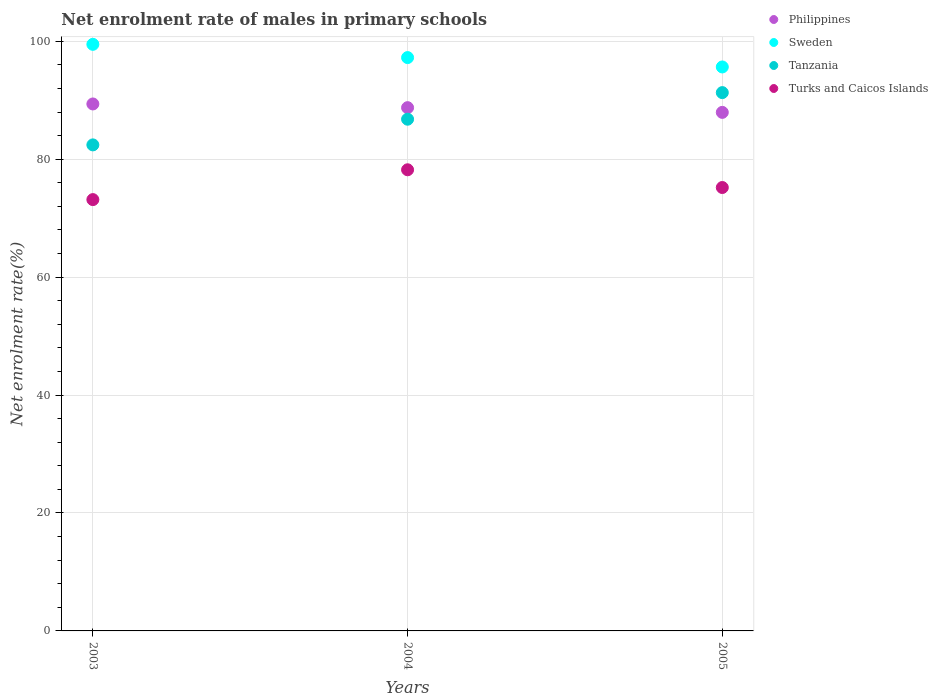What is the net enrolment rate of males in primary schools in Philippines in 2004?
Keep it short and to the point. 88.75. Across all years, what is the maximum net enrolment rate of males in primary schools in Philippines?
Provide a succinct answer. 89.37. Across all years, what is the minimum net enrolment rate of males in primary schools in Turks and Caicos Islands?
Your answer should be compact. 73.15. What is the total net enrolment rate of males in primary schools in Sweden in the graph?
Your answer should be very brief. 292.38. What is the difference between the net enrolment rate of males in primary schools in Philippines in 2003 and that in 2005?
Your answer should be compact. 1.43. What is the difference between the net enrolment rate of males in primary schools in Turks and Caicos Islands in 2003 and the net enrolment rate of males in primary schools in Philippines in 2005?
Make the answer very short. -14.79. What is the average net enrolment rate of males in primary schools in Philippines per year?
Give a very brief answer. 88.69. In the year 2005, what is the difference between the net enrolment rate of males in primary schools in Tanzania and net enrolment rate of males in primary schools in Sweden?
Offer a very short reply. -4.35. What is the ratio of the net enrolment rate of males in primary schools in Sweden in 2004 to that in 2005?
Provide a succinct answer. 1.02. Is the difference between the net enrolment rate of males in primary schools in Tanzania in 2003 and 2005 greater than the difference between the net enrolment rate of males in primary schools in Sweden in 2003 and 2005?
Offer a terse response. No. What is the difference between the highest and the second highest net enrolment rate of males in primary schools in Tanzania?
Make the answer very short. 4.51. What is the difference between the highest and the lowest net enrolment rate of males in primary schools in Philippines?
Ensure brevity in your answer.  1.43. In how many years, is the net enrolment rate of males in primary schools in Sweden greater than the average net enrolment rate of males in primary schools in Sweden taken over all years?
Keep it short and to the point. 1. Is the sum of the net enrolment rate of males in primary schools in Tanzania in 2003 and 2004 greater than the maximum net enrolment rate of males in primary schools in Sweden across all years?
Give a very brief answer. Yes. Is it the case that in every year, the sum of the net enrolment rate of males in primary schools in Tanzania and net enrolment rate of males in primary schools in Philippines  is greater than the sum of net enrolment rate of males in primary schools in Sweden and net enrolment rate of males in primary schools in Turks and Caicos Islands?
Ensure brevity in your answer.  No. Is it the case that in every year, the sum of the net enrolment rate of males in primary schools in Sweden and net enrolment rate of males in primary schools in Turks and Caicos Islands  is greater than the net enrolment rate of males in primary schools in Philippines?
Make the answer very short. Yes. How many dotlines are there?
Your response must be concise. 4. What is the difference between two consecutive major ticks on the Y-axis?
Offer a very short reply. 20. Are the values on the major ticks of Y-axis written in scientific E-notation?
Offer a terse response. No. Does the graph contain any zero values?
Offer a very short reply. No. Does the graph contain grids?
Give a very brief answer. Yes. Where does the legend appear in the graph?
Provide a short and direct response. Top right. How many legend labels are there?
Your answer should be very brief. 4. How are the legend labels stacked?
Offer a very short reply. Vertical. What is the title of the graph?
Offer a very short reply. Net enrolment rate of males in primary schools. Does "Lithuania" appear as one of the legend labels in the graph?
Offer a terse response. No. What is the label or title of the Y-axis?
Make the answer very short. Net enrolment rate(%). What is the Net enrolment rate(%) in Philippines in 2003?
Your response must be concise. 89.37. What is the Net enrolment rate(%) in Sweden in 2003?
Offer a terse response. 99.49. What is the Net enrolment rate(%) of Tanzania in 2003?
Keep it short and to the point. 82.43. What is the Net enrolment rate(%) of Turks and Caicos Islands in 2003?
Keep it short and to the point. 73.15. What is the Net enrolment rate(%) in Philippines in 2004?
Offer a very short reply. 88.75. What is the Net enrolment rate(%) in Sweden in 2004?
Keep it short and to the point. 97.24. What is the Net enrolment rate(%) in Tanzania in 2004?
Offer a very short reply. 86.79. What is the Net enrolment rate(%) in Turks and Caicos Islands in 2004?
Provide a short and direct response. 78.21. What is the Net enrolment rate(%) in Philippines in 2005?
Offer a very short reply. 87.95. What is the Net enrolment rate(%) of Sweden in 2005?
Offer a terse response. 95.65. What is the Net enrolment rate(%) in Tanzania in 2005?
Your answer should be compact. 91.3. What is the Net enrolment rate(%) of Turks and Caicos Islands in 2005?
Provide a succinct answer. 75.2. Across all years, what is the maximum Net enrolment rate(%) of Philippines?
Ensure brevity in your answer.  89.37. Across all years, what is the maximum Net enrolment rate(%) in Sweden?
Your response must be concise. 99.49. Across all years, what is the maximum Net enrolment rate(%) of Tanzania?
Provide a succinct answer. 91.3. Across all years, what is the maximum Net enrolment rate(%) of Turks and Caicos Islands?
Keep it short and to the point. 78.21. Across all years, what is the minimum Net enrolment rate(%) in Philippines?
Keep it short and to the point. 87.95. Across all years, what is the minimum Net enrolment rate(%) of Sweden?
Give a very brief answer. 95.65. Across all years, what is the minimum Net enrolment rate(%) in Tanzania?
Offer a terse response. 82.43. Across all years, what is the minimum Net enrolment rate(%) of Turks and Caicos Islands?
Provide a short and direct response. 73.15. What is the total Net enrolment rate(%) of Philippines in the graph?
Your answer should be very brief. 266.07. What is the total Net enrolment rate(%) of Sweden in the graph?
Ensure brevity in your answer.  292.38. What is the total Net enrolment rate(%) in Tanzania in the graph?
Offer a very short reply. 260.52. What is the total Net enrolment rate(%) in Turks and Caicos Islands in the graph?
Keep it short and to the point. 226.57. What is the difference between the Net enrolment rate(%) of Philippines in 2003 and that in 2004?
Your response must be concise. 0.63. What is the difference between the Net enrolment rate(%) of Sweden in 2003 and that in 2004?
Provide a short and direct response. 2.25. What is the difference between the Net enrolment rate(%) of Tanzania in 2003 and that in 2004?
Provide a succinct answer. -4.35. What is the difference between the Net enrolment rate(%) in Turks and Caicos Islands in 2003 and that in 2004?
Offer a terse response. -5.06. What is the difference between the Net enrolment rate(%) in Philippines in 2003 and that in 2005?
Offer a very short reply. 1.43. What is the difference between the Net enrolment rate(%) of Sweden in 2003 and that in 2005?
Your answer should be compact. 3.84. What is the difference between the Net enrolment rate(%) in Tanzania in 2003 and that in 2005?
Ensure brevity in your answer.  -8.87. What is the difference between the Net enrolment rate(%) in Turks and Caicos Islands in 2003 and that in 2005?
Provide a succinct answer. -2.05. What is the difference between the Net enrolment rate(%) in Philippines in 2004 and that in 2005?
Keep it short and to the point. 0.8. What is the difference between the Net enrolment rate(%) in Sweden in 2004 and that in 2005?
Make the answer very short. 1.59. What is the difference between the Net enrolment rate(%) of Tanzania in 2004 and that in 2005?
Ensure brevity in your answer.  -4.51. What is the difference between the Net enrolment rate(%) in Turks and Caicos Islands in 2004 and that in 2005?
Give a very brief answer. 3.01. What is the difference between the Net enrolment rate(%) of Philippines in 2003 and the Net enrolment rate(%) of Sweden in 2004?
Make the answer very short. -7.87. What is the difference between the Net enrolment rate(%) of Philippines in 2003 and the Net enrolment rate(%) of Tanzania in 2004?
Make the answer very short. 2.59. What is the difference between the Net enrolment rate(%) in Philippines in 2003 and the Net enrolment rate(%) in Turks and Caicos Islands in 2004?
Give a very brief answer. 11.16. What is the difference between the Net enrolment rate(%) in Sweden in 2003 and the Net enrolment rate(%) in Tanzania in 2004?
Keep it short and to the point. 12.7. What is the difference between the Net enrolment rate(%) in Sweden in 2003 and the Net enrolment rate(%) in Turks and Caicos Islands in 2004?
Keep it short and to the point. 21.28. What is the difference between the Net enrolment rate(%) of Tanzania in 2003 and the Net enrolment rate(%) of Turks and Caicos Islands in 2004?
Ensure brevity in your answer.  4.22. What is the difference between the Net enrolment rate(%) of Philippines in 2003 and the Net enrolment rate(%) of Sweden in 2005?
Keep it short and to the point. -6.28. What is the difference between the Net enrolment rate(%) of Philippines in 2003 and the Net enrolment rate(%) of Tanzania in 2005?
Make the answer very short. -1.93. What is the difference between the Net enrolment rate(%) of Philippines in 2003 and the Net enrolment rate(%) of Turks and Caicos Islands in 2005?
Your answer should be compact. 14.17. What is the difference between the Net enrolment rate(%) of Sweden in 2003 and the Net enrolment rate(%) of Tanzania in 2005?
Ensure brevity in your answer.  8.19. What is the difference between the Net enrolment rate(%) of Sweden in 2003 and the Net enrolment rate(%) of Turks and Caicos Islands in 2005?
Make the answer very short. 24.28. What is the difference between the Net enrolment rate(%) in Tanzania in 2003 and the Net enrolment rate(%) in Turks and Caicos Islands in 2005?
Your answer should be compact. 7.23. What is the difference between the Net enrolment rate(%) in Philippines in 2004 and the Net enrolment rate(%) in Sweden in 2005?
Your response must be concise. -6.9. What is the difference between the Net enrolment rate(%) in Philippines in 2004 and the Net enrolment rate(%) in Tanzania in 2005?
Provide a succinct answer. -2.55. What is the difference between the Net enrolment rate(%) of Philippines in 2004 and the Net enrolment rate(%) of Turks and Caicos Islands in 2005?
Offer a terse response. 13.54. What is the difference between the Net enrolment rate(%) of Sweden in 2004 and the Net enrolment rate(%) of Tanzania in 2005?
Your response must be concise. 5.94. What is the difference between the Net enrolment rate(%) of Sweden in 2004 and the Net enrolment rate(%) of Turks and Caicos Islands in 2005?
Your answer should be very brief. 22.04. What is the difference between the Net enrolment rate(%) of Tanzania in 2004 and the Net enrolment rate(%) of Turks and Caicos Islands in 2005?
Offer a very short reply. 11.58. What is the average Net enrolment rate(%) of Philippines per year?
Provide a succinct answer. 88.69. What is the average Net enrolment rate(%) in Sweden per year?
Your answer should be very brief. 97.46. What is the average Net enrolment rate(%) in Tanzania per year?
Offer a very short reply. 86.84. What is the average Net enrolment rate(%) in Turks and Caicos Islands per year?
Your answer should be very brief. 75.52. In the year 2003, what is the difference between the Net enrolment rate(%) of Philippines and Net enrolment rate(%) of Sweden?
Offer a very short reply. -10.11. In the year 2003, what is the difference between the Net enrolment rate(%) in Philippines and Net enrolment rate(%) in Tanzania?
Keep it short and to the point. 6.94. In the year 2003, what is the difference between the Net enrolment rate(%) in Philippines and Net enrolment rate(%) in Turks and Caicos Islands?
Make the answer very short. 16.22. In the year 2003, what is the difference between the Net enrolment rate(%) of Sweden and Net enrolment rate(%) of Tanzania?
Give a very brief answer. 17.05. In the year 2003, what is the difference between the Net enrolment rate(%) in Sweden and Net enrolment rate(%) in Turks and Caicos Islands?
Provide a succinct answer. 26.33. In the year 2003, what is the difference between the Net enrolment rate(%) of Tanzania and Net enrolment rate(%) of Turks and Caicos Islands?
Give a very brief answer. 9.28. In the year 2004, what is the difference between the Net enrolment rate(%) of Philippines and Net enrolment rate(%) of Sweden?
Your answer should be compact. -8.49. In the year 2004, what is the difference between the Net enrolment rate(%) in Philippines and Net enrolment rate(%) in Tanzania?
Make the answer very short. 1.96. In the year 2004, what is the difference between the Net enrolment rate(%) in Philippines and Net enrolment rate(%) in Turks and Caicos Islands?
Provide a short and direct response. 10.54. In the year 2004, what is the difference between the Net enrolment rate(%) of Sweden and Net enrolment rate(%) of Tanzania?
Offer a very short reply. 10.45. In the year 2004, what is the difference between the Net enrolment rate(%) of Sweden and Net enrolment rate(%) of Turks and Caicos Islands?
Your answer should be very brief. 19.03. In the year 2004, what is the difference between the Net enrolment rate(%) of Tanzania and Net enrolment rate(%) of Turks and Caicos Islands?
Ensure brevity in your answer.  8.58. In the year 2005, what is the difference between the Net enrolment rate(%) of Philippines and Net enrolment rate(%) of Sweden?
Your answer should be very brief. -7.7. In the year 2005, what is the difference between the Net enrolment rate(%) in Philippines and Net enrolment rate(%) in Tanzania?
Your answer should be compact. -3.35. In the year 2005, what is the difference between the Net enrolment rate(%) of Philippines and Net enrolment rate(%) of Turks and Caicos Islands?
Ensure brevity in your answer.  12.74. In the year 2005, what is the difference between the Net enrolment rate(%) of Sweden and Net enrolment rate(%) of Tanzania?
Provide a succinct answer. 4.35. In the year 2005, what is the difference between the Net enrolment rate(%) of Sweden and Net enrolment rate(%) of Turks and Caicos Islands?
Your response must be concise. 20.45. In the year 2005, what is the difference between the Net enrolment rate(%) in Tanzania and Net enrolment rate(%) in Turks and Caicos Islands?
Offer a terse response. 16.1. What is the ratio of the Net enrolment rate(%) in Philippines in 2003 to that in 2004?
Your answer should be very brief. 1.01. What is the ratio of the Net enrolment rate(%) in Sweden in 2003 to that in 2004?
Provide a succinct answer. 1.02. What is the ratio of the Net enrolment rate(%) of Tanzania in 2003 to that in 2004?
Provide a succinct answer. 0.95. What is the ratio of the Net enrolment rate(%) in Turks and Caicos Islands in 2003 to that in 2004?
Offer a terse response. 0.94. What is the ratio of the Net enrolment rate(%) of Philippines in 2003 to that in 2005?
Offer a terse response. 1.02. What is the ratio of the Net enrolment rate(%) in Sweden in 2003 to that in 2005?
Provide a short and direct response. 1.04. What is the ratio of the Net enrolment rate(%) of Tanzania in 2003 to that in 2005?
Provide a short and direct response. 0.9. What is the ratio of the Net enrolment rate(%) of Turks and Caicos Islands in 2003 to that in 2005?
Keep it short and to the point. 0.97. What is the ratio of the Net enrolment rate(%) in Philippines in 2004 to that in 2005?
Your answer should be very brief. 1.01. What is the ratio of the Net enrolment rate(%) in Sweden in 2004 to that in 2005?
Offer a very short reply. 1.02. What is the ratio of the Net enrolment rate(%) in Tanzania in 2004 to that in 2005?
Make the answer very short. 0.95. What is the difference between the highest and the second highest Net enrolment rate(%) of Philippines?
Provide a succinct answer. 0.63. What is the difference between the highest and the second highest Net enrolment rate(%) of Sweden?
Provide a short and direct response. 2.25. What is the difference between the highest and the second highest Net enrolment rate(%) in Tanzania?
Keep it short and to the point. 4.51. What is the difference between the highest and the second highest Net enrolment rate(%) in Turks and Caicos Islands?
Provide a succinct answer. 3.01. What is the difference between the highest and the lowest Net enrolment rate(%) in Philippines?
Offer a very short reply. 1.43. What is the difference between the highest and the lowest Net enrolment rate(%) in Sweden?
Make the answer very short. 3.84. What is the difference between the highest and the lowest Net enrolment rate(%) in Tanzania?
Provide a succinct answer. 8.87. What is the difference between the highest and the lowest Net enrolment rate(%) in Turks and Caicos Islands?
Provide a short and direct response. 5.06. 